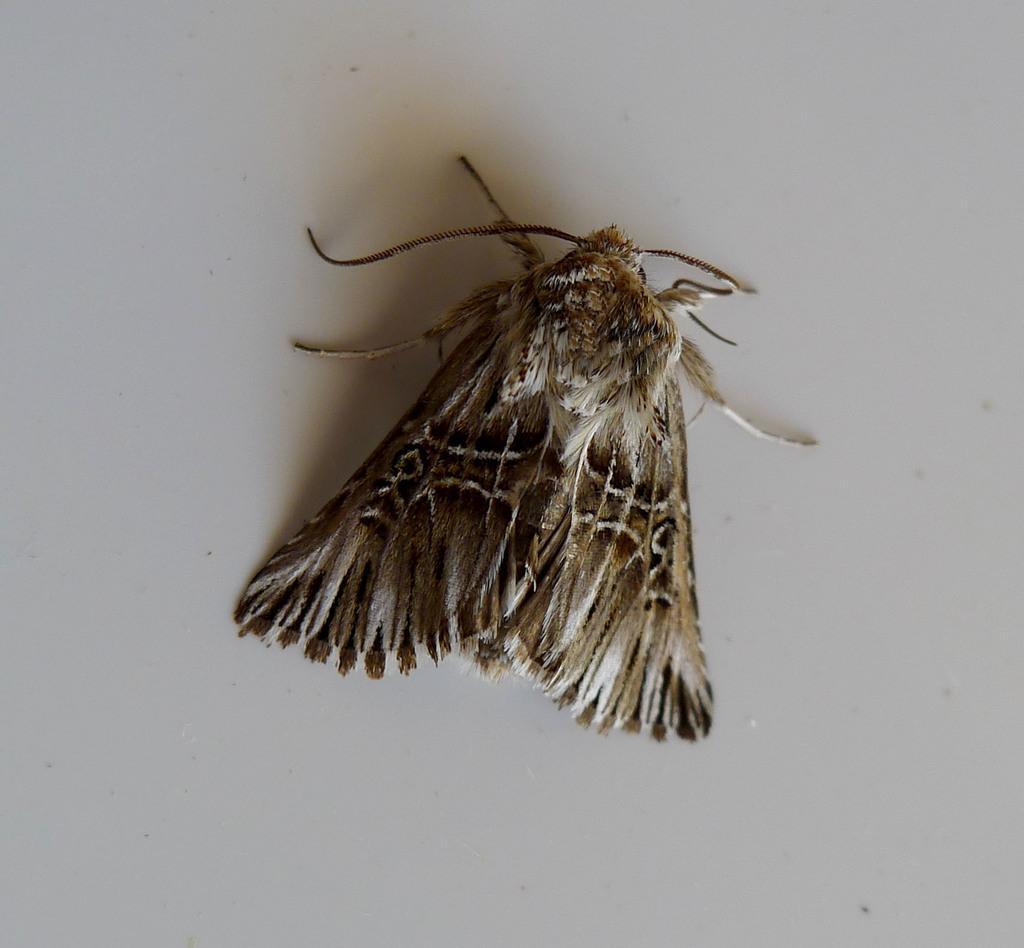Can you describe this image briefly? In this image there is an insect on the path. 